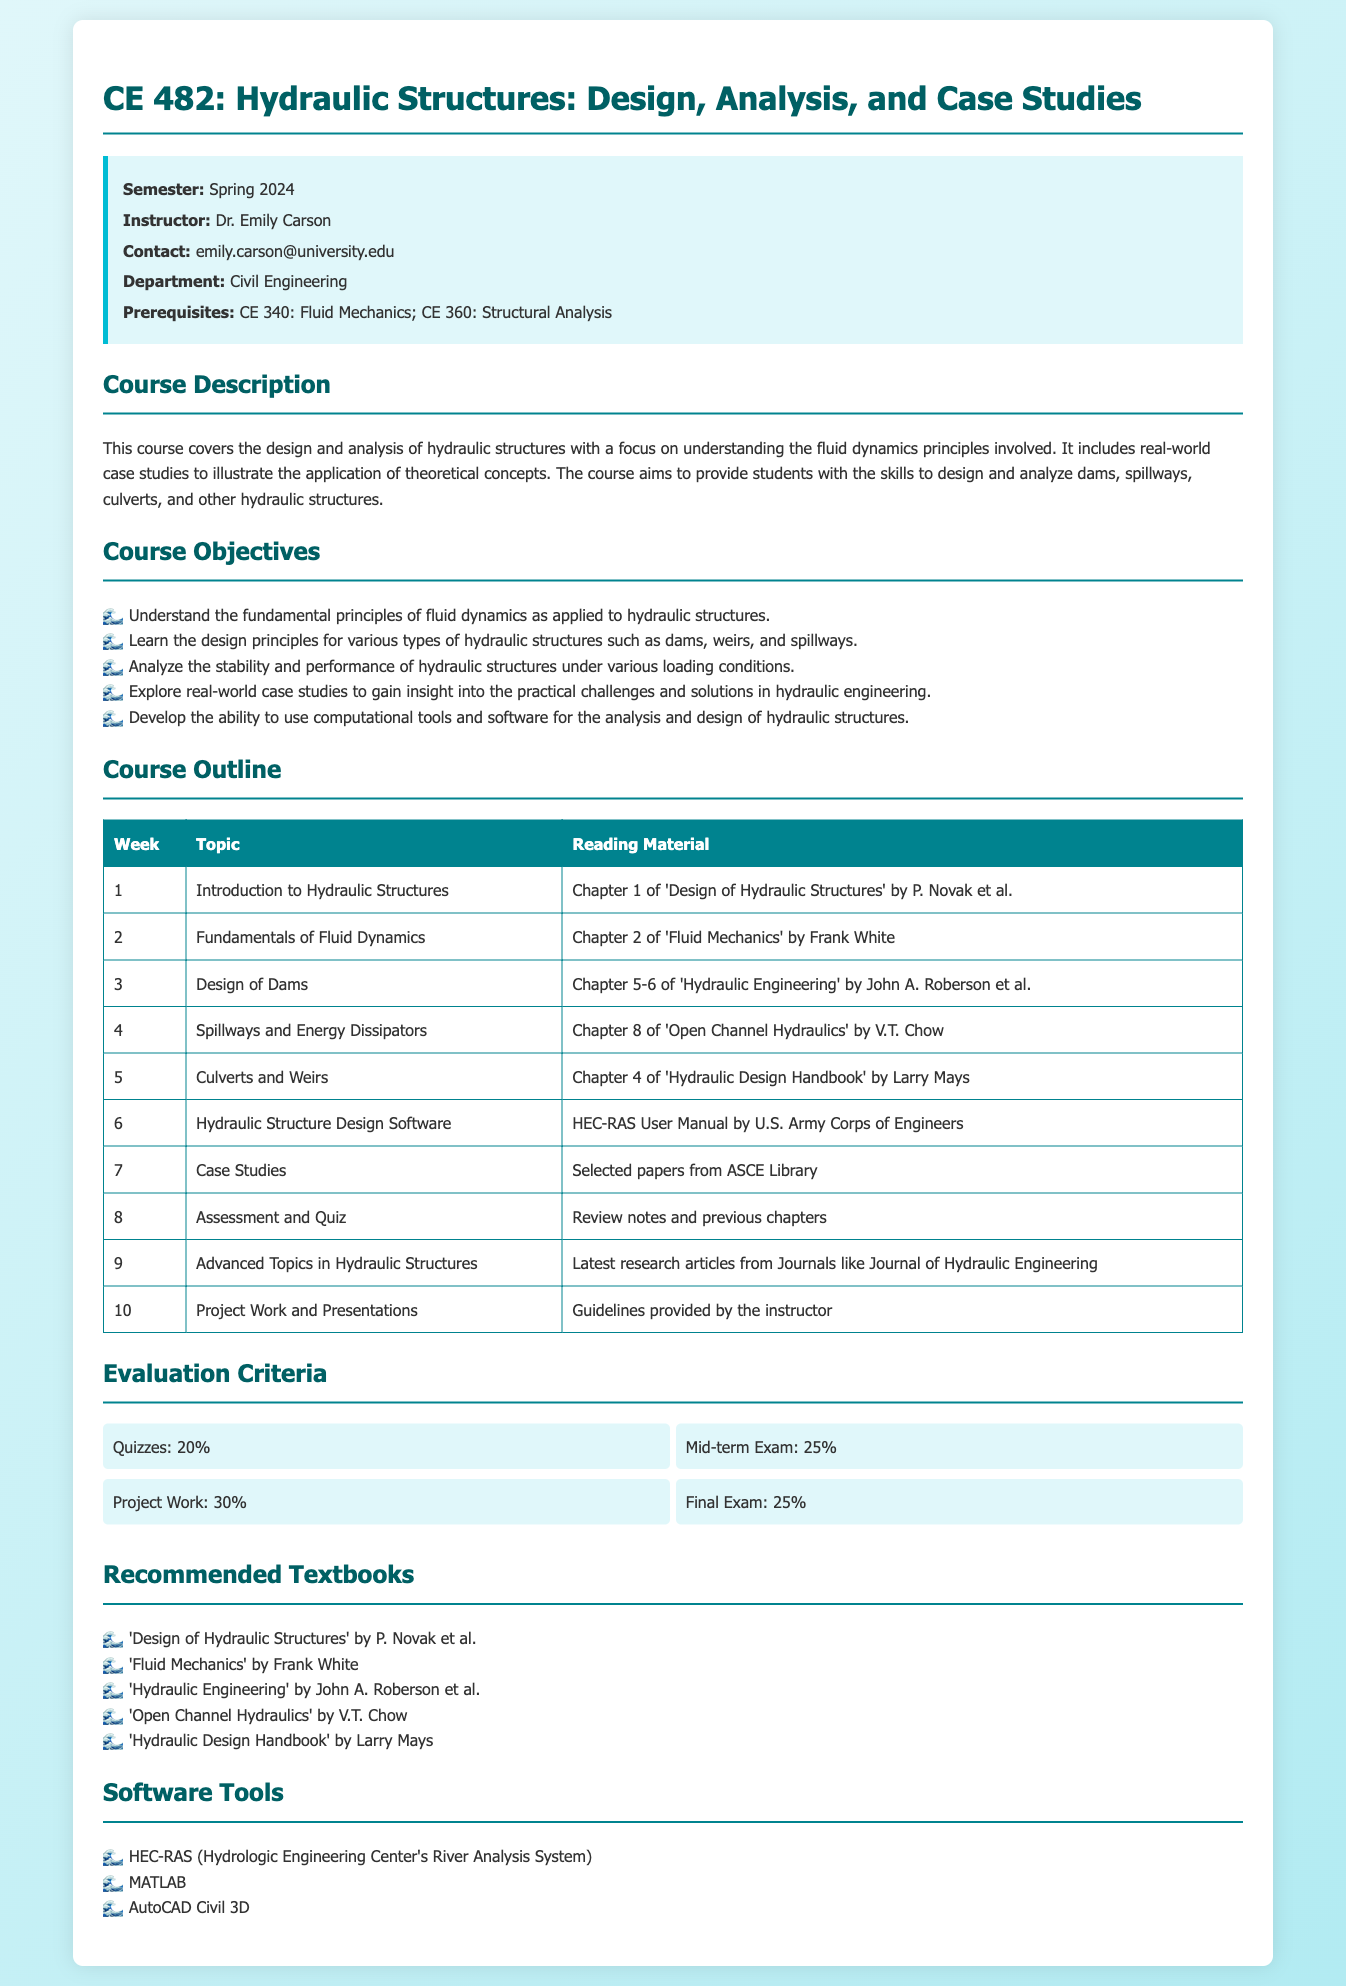What is the course title? The course title is listed at the top of the syllabus under the course name section.
Answer: CE 482: Hydraulic Structures: Design, Analysis, and Case Studies Who is the instructor of the course? The instructor's name is provided in the information box on the document.
Answer: Dr. Emily Carson What is the prerequisite course for CE 482? The prerequisites for the course are stated in the info box under prerequisites section.
Answer: CE 340: Fluid Mechanics; CE 360: Structural Analysis What percentage of the evaluation is based on Project Work? The evaluation criteria section lists the percentages for each evaluation component.
Answer: 30% Which software tools are recommended for this course? The recommended software tools are listed under the software tools section in the syllabus.
Answer: HEC-RAS, MATLAB, AutoCAD Civil 3D What week covers the design of dams? The week covering the design of dams is specified in the course outline table.
Answer: Week 3 What is the total percentage of quizzes in the evaluation criteria? The evaluation section provides the percentage for quizzes, requiring summation knowledge.
Answer: 20% How many case studies will be discussed in the course? The course outline mentions a specific week dedicated to case studies.
Answer: One week (Week 7) 